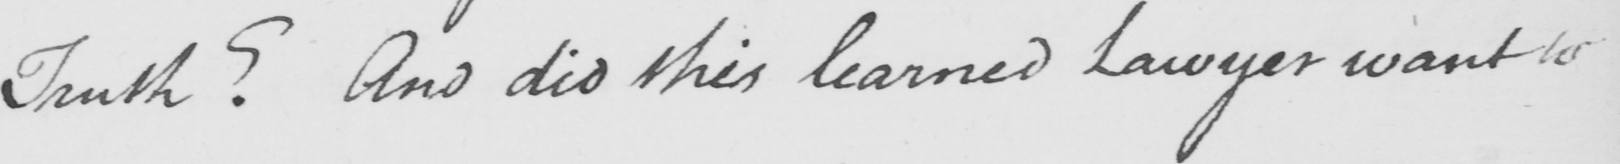Can you read and transcribe this handwriting? Truth ?  And did this learned Lawyer want to 